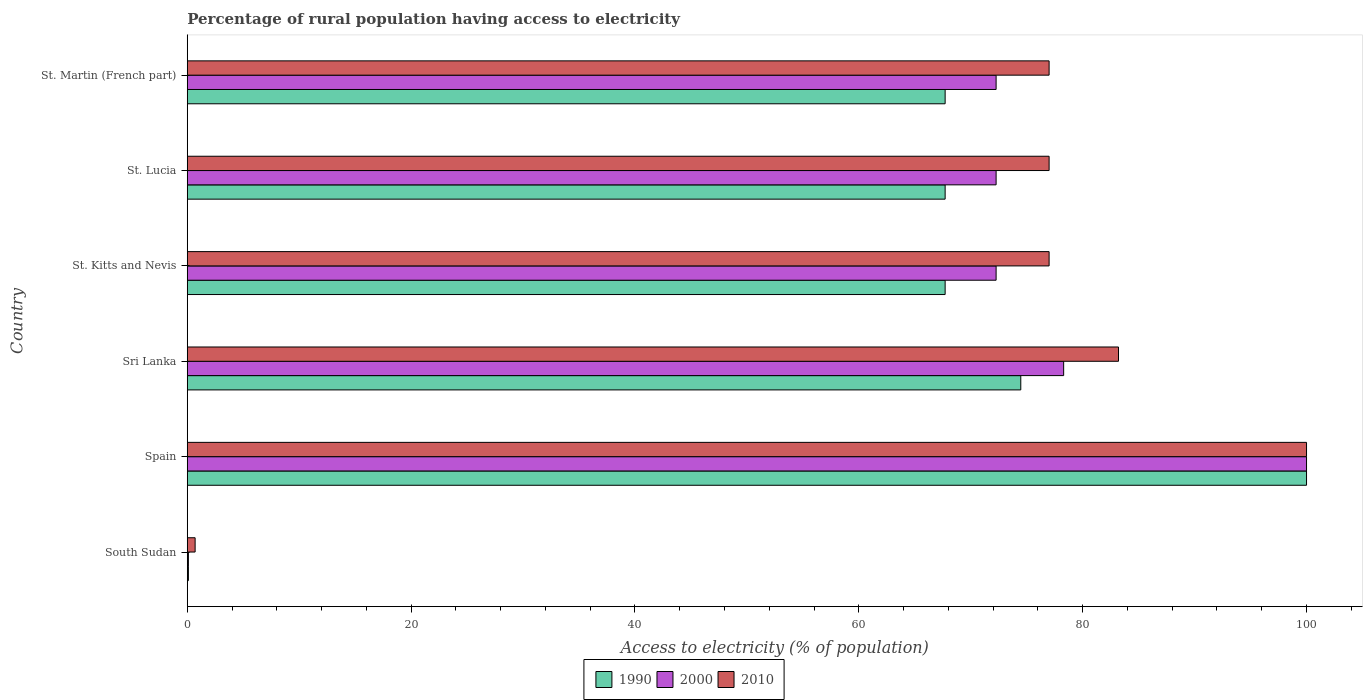How many groups of bars are there?
Offer a terse response. 6. Are the number of bars per tick equal to the number of legend labels?
Provide a short and direct response. Yes. Are the number of bars on each tick of the Y-axis equal?
Ensure brevity in your answer.  Yes. How many bars are there on the 4th tick from the bottom?
Provide a short and direct response. 3. What is the label of the 4th group of bars from the top?
Provide a succinct answer. Sri Lanka. What is the percentage of rural population having access to electricity in 2000 in South Sudan?
Offer a terse response. 0.1. In which country was the percentage of rural population having access to electricity in 2010 minimum?
Give a very brief answer. South Sudan. What is the total percentage of rural population having access to electricity in 1990 in the graph?
Provide a succinct answer. 377.7. What is the difference between the percentage of rural population having access to electricity in 2010 in Sri Lanka and that in St. Lucia?
Provide a succinct answer. 6.2. What is the difference between the percentage of rural population having access to electricity in 1990 in Sri Lanka and the percentage of rural population having access to electricity in 2000 in Spain?
Give a very brief answer. -25.53. What is the average percentage of rural population having access to electricity in 2000 per country?
Ensure brevity in your answer.  65.87. What is the difference between the percentage of rural population having access to electricity in 2010 and percentage of rural population having access to electricity in 2000 in St. Lucia?
Offer a terse response. 4.73. In how many countries, is the percentage of rural population having access to electricity in 1990 greater than 48 %?
Give a very brief answer. 5. What is the ratio of the percentage of rural population having access to electricity in 2000 in South Sudan to that in Spain?
Give a very brief answer. 0. Is the percentage of rural population having access to electricity in 2010 in Spain less than that in Sri Lanka?
Offer a terse response. No. Is the difference between the percentage of rural population having access to electricity in 2010 in St. Lucia and St. Martin (French part) greater than the difference between the percentage of rural population having access to electricity in 2000 in St. Lucia and St. Martin (French part)?
Offer a terse response. No. What is the difference between the highest and the second highest percentage of rural population having access to electricity in 2000?
Provide a succinct answer. 21.7. What is the difference between the highest and the lowest percentage of rural population having access to electricity in 2000?
Your answer should be compact. 99.9. What does the 2nd bar from the top in St. Martin (French part) represents?
Provide a succinct answer. 2000. Is it the case that in every country, the sum of the percentage of rural population having access to electricity in 1990 and percentage of rural population having access to electricity in 2010 is greater than the percentage of rural population having access to electricity in 2000?
Offer a very short reply. Yes. How many bars are there?
Your response must be concise. 18. How many countries are there in the graph?
Your answer should be very brief. 6. What is the difference between two consecutive major ticks on the X-axis?
Offer a terse response. 20. Are the values on the major ticks of X-axis written in scientific E-notation?
Offer a very short reply. No. Where does the legend appear in the graph?
Your answer should be compact. Bottom center. How many legend labels are there?
Ensure brevity in your answer.  3. What is the title of the graph?
Keep it short and to the point. Percentage of rural population having access to electricity. Does "1976" appear as one of the legend labels in the graph?
Offer a very short reply. No. What is the label or title of the X-axis?
Offer a terse response. Access to electricity (% of population). What is the Access to electricity (% of population) in 1990 in South Sudan?
Ensure brevity in your answer.  0.1. What is the Access to electricity (% of population) of 1990 in Spain?
Offer a very short reply. 100. What is the Access to electricity (% of population) in 1990 in Sri Lanka?
Provide a succinct answer. 74.47. What is the Access to electricity (% of population) of 2000 in Sri Lanka?
Your response must be concise. 78.3. What is the Access to electricity (% of population) of 2010 in Sri Lanka?
Keep it short and to the point. 83.2. What is the Access to electricity (% of population) of 1990 in St. Kitts and Nevis?
Provide a short and direct response. 67.71. What is the Access to electricity (% of population) of 2000 in St. Kitts and Nevis?
Keep it short and to the point. 72.27. What is the Access to electricity (% of population) of 2010 in St. Kitts and Nevis?
Your answer should be very brief. 77. What is the Access to electricity (% of population) of 1990 in St. Lucia?
Offer a very short reply. 67.71. What is the Access to electricity (% of population) in 2000 in St. Lucia?
Offer a terse response. 72.27. What is the Access to electricity (% of population) in 2010 in St. Lucia?
Your answer should be very brief. 77. What is the Access to electricity (% of population) of 1990 in St. Martin (French part)?
Provide a succinct answer. 67.71. What is the Access to electricity (% of population) in 2000 in St. Martin (French part)?
Provide a short and direct response. 72.27. What is the Access to electricity (% of population) of 2010 in St. Martin (French part)?
Give a very brief answer. 77. Across all countries, what is the maximum Access to electricity (% of population) in 1990?
Offer a terse response. 100. Across all countries, what is the maximum Access to electricity (% of population) of 2000?
Provide a short and direct response. 100. Across all countries, what is the minimum Access to electricity (% of population) in 1990?
Offer a very short reply. 0.1. Across all countries, what is the minimum Access to electricity (% of population) in 2000?
Your response must be concise. 0.1. Across all countries, what is the minimum Access to electricity (% of population) of 2010?
Your response must be concise. 0.7. What is the total Access to electricity (% of population) in 1990 in the graph?
Give a very brief answer. 377.7. What is the total Access to electricity (% of population) in 2000 in the graph?
Give a very brief answer. 395.2. What is the total Access to electricity (% of population) in 2010 in the graph?
Keep it short and to the point. 414.9. What is the difference between the Access to electricity (% of population) of 1990 in South Sudan and that in Spain?
Give a very brief answer. -99.9. What is the difference between the Access to electricity (% of population) in 2000 in South Sudan and that in Spain?
Ensure brevity in your answer.  -99.9. What is the difference between the Access to electricity (% of population) of 2010 in South Sudan and that in Spain?
Provide a short and direct response. -99.3. What is the difference between the Access to electricity (% of population) of 1990 in South Sudan and that in Sri Lanka?
Provide a short and direct response. -74.37. What is the difference between the Access to electricity (% of population) in 2000 in South Sudan and that in Sri Lanka?
Your response must be concise. -78.2. What is the difference between the Access to electricity (% of population) in 2010 in South Sudan and that in Sri Lanka?
Your response must be concise. -82.5. What is the difference between the Access to electricity (% of population) of 1990 in South Sudan and that in St. Kitts and Nevis?
Offer a terse response. -67.61. What is the difference between the Access to electricity (% of population) in 2000 in South Sudan and that in St. Kitts and Nevis?
Offer a very short reply. -72.17. What is the difference between the Access to electricity (% of population) of 2010 in South Sudan and that in St. Kitts and Nevis?
Offer a terse response. -76.3. What is the difference between the Access to electricity (% of population) in 1990 in South Sudan and that in St. Lucia?
Provide a succinct answer. -67.61. What is the difference between the Access to electricity (% of population) in 2000 in South Sudan and that in St. Lucia?
Your answer should be compact. -72.17. What is the difference between the Access to electricity (% of population) of 2010 in South Sudan and that in St. Lucia?
Offer a very short reply. -76.3. What is the difference between the Access to electricity (% of population) in 1990 in South Sudan and that in St. Martin (French part)?
Keep it short and to the point. -67.61. What is the difference between the Access to electricity (% of population) of 2000 in South Sudan and that in St. Martin (French part)?
Your answer should be very brief. -72.17. What is the difference between the Access to electricity (% of population) in 2010 in South Sudan and that in St. Martin (French part)?
Make the answer very short. -76.3. What is the difference between the Access to electricity (% of population) of 1990 in Spain and that in Sri Lanka?
Your response must be concise. 25.53. What is the difference between the Access to electricity (% of population) in 2000 in Spain and that in Sri Lanka?
Give a very brief answer. 21.7. What is the difference between the Access to electricity (% of population) in 2010 in Spain and that in Sri Lanka?
Your answer should be compact. 16.8. What is the difference between the Access to electricity (% of population) of 1990 in Spain and that in St. Kitts and Nevis?
Offer a very short reply. 32.29. What is the difference between the Access to electricity (% of population) of 2000 in Spain and that in St. Kitts and Nevis?
Provide a short and direct response. 27.73. What is the difference between the Access to electricity (% of population) of 2010 in Spain and that in St. Kitts and Nevis?
Make the answer very short. 23. What is the difference between the Access to electricity (% of population) in 1990 in Spain and that in St. Lucia?
Provide a succinct answer. 32.29. What is the difference between the Access to electricity (% of population) of 2000 in Spain and that in St. Lucia?
Offer a terse response. 27.73. What is the difference between the Access to electricity (% of population) of 2010 in Spain and that in St. Lucia?
Offer a very short reply. 23. What is the difference between the Access to electricity (% of population) of 1990 in Spain and that in St. Martin (French part)?
Your response must be concise. 32.29. What is the difference between the Access to electricity (% of population) in 2000 in Spain and that in St. Martin (French part)?
Offer a terse response. 27.73. What is the difference between the Access to electricity (% of population) of 2010 in Spain and that in St. Martin (French part)?
Make the answer very short. 23. What is the difference between the Access to electricity (% of population) in 1990 in Sri Lanka and that in St. Kitts and Nevis?
Ensure brevity in your answer.  6.76. What is the difference between the Access to electricity (% of population) of 2000 in Sri Lanka and that in St. Kitts and Nevis?
Keep it short and to the point. 6.04. What is the difference between the Access to electricity (% of population) in 1990 in Sri Lanka and that in St. Lucia?
Your response must be concise. 6.76. What is the difference between the Access to electricity (% of population) in 2000 in Sri Lanka and that in St. Lucia?
Offer a very short reply. 6.04. What is the difference between the Access to electricity (% of population) of 2010 in Sri Lanka and that in St. Lucia?
Offer a very short reply. 6.2. What is the difference between the Access to electricity (% of population) of 1990 in Sri Lanka and that in St. Martin (French part)?
Offer a very short reply. 6.76. What is the difference between the Access to electricity (% of population) in 2000 in Sri Lanka and that in St. Martin (French part)?
Ensure brevity in your answer.  6.04. What is the difference between the Access to electricity (% of population) in 2010 in Sri Lanka and that in St. Martin (French part)?
Provide a succinct answer. 6.2. What is the difference between the Access to electricity (% of population) of 2010 in St. Kitts and Nevis and that in St. Lucia?
Your response must be concise. 0. What is the difference between the Access to electricity (% of population) of 1990 in St. Kitts and Nevis and that in St. Martin (French part)?
Offer a very short reply. 0. What is the difference between the Access to electricity (% of population) in 2000 in St. Kitts and Nevis and that in St. Martin (French part)?
Your answer should be very brief. 0. What is the difference between the Access to electricity (% of population) of 1990 in St. Lucia and that in St. Martin (French part)?
Provide a succinct answer. 0. What is the difference between the Access to electricity (% of population) of 2000 in St. Lucia and that in St. Martin (French part)?
Your answer should be very brief. 0. What is the difference between the Access to electricity (% of population) of 1990 in South Sudan and the Access to electricity (% of population) of 2000 in Spain?
Your answer should be compact. -99.9. What is the difference between the Access to electricity (% of population) of 1990 in South Sudan and the Access to electricity (% of population) of 2010 in Spain?
Keep it short and to the point. -99.9. What is the difference between the Access to electricity (% of population) of 2000 in South Sudan and the Access to electricity (% of population) of 2010 in Spain?
Make the answer very short. -99.9. What is the difference between the Access to electricity (% of population) in 1990 in South Sudan and the Access to electricity (% of population) in 2000 in Sri Lanka?
Your answer should be very brief. -78.2. What is the difference between the Access to electricity (% of population) of 1990 in South Sudan and the Access to electricity (% of population) of 2010 in Sri Lanka?
Your answer should be very brief. -83.1. What is the difference between the Access to electricity (% of population) in 2000 in South Sudan and the Access to electricity (% of population) in 2010 in Sri Lanka?
Your answer should be compact. -83.1. What is the difference between the Access to electricity (% of population) of 1990 in South Sudan and the Access to electricity (% of population) of 2000 in St. Kitts and Nevis?
Ensure brevity in your answer.  -72.17. What is the difference between the Access to electricity (% of population) of 1990 in South Sudan and the Access to electricity (% of population) of 2010 in St. Kitts and Nevis?
Give a very brief answer. -76.9. What is the difference between the Access to electricity (% of population) in 2000 in South Sudan and the Access to electricity (% of population) in 2010 in St. Kitts and Nevis?
Your response must be concise. -76.9. What is the difference between the Access to electricity (% of population) of 1990 in South Sudan and the Access to electricity (% of population) of 2000 in St. Lucia?
Ensure brevity in your answer.  -72.17. What is the difference between the Access to electricity (% of population) in 1990 in South Sudan and the Access to electricity (% of population) in 2010 in St. Lucia?
Provide a succinct answer. -76.9. What is the difference between the Access to electricity (% of population) in 2000 in South Sudan and the Access to electricity (% of population) in 2010 in St. Lucia?
Provide a succinct answer. -76.9. What is the difference between the Access to electricity (% of population) in 1990 in South Sudan and the Access to electricity (% of population) in 2000 in St. Martin (French part)?
Ensure brevity in your answer.  -72.17. What is the difference between the Access to electricity (% of population) in 1990 in South Sudan and the Access to electricity (% of population) in 2010 in St. Martin (French part)?
Give a very brief answer. -76.9. What is the difference between the Access to electricity (% of population) in 2000 in South Sudan and the Access to electricity (% of population) in 2010 in St. Martin (French part)?
Provide a succinct answer. -76.9. What is the difference between the Access to electricity (% of population) in 1990 in Spain and the Access to electricity (% of population) in 2000 in Sri Lanka?
Your answer should be very brief. 21.7. What is the difference between the Access to electricity (% of population) in 1990 in Spain and the Access to electricity (% of population) in 2000 in St. Kitts and Nevis?
Your answer should be compact. 27.73. What is the difference between the Access to electricity (% of population) in 1990 in Spain and the Access to electricity (% of population) in 2000 in St. Lucia?
Your answer should be compact. 27.73. What is the difference between the Access to electricity (% of population) in 2000 in Spain and the Access to electricity (% of population) in 2010 in St. Lucia?
Keep it short and to the point. 23. What is the difference between the Access to electricity (% of population) of 1990 in Spain and the Access to electricity (% of population) of 2000 in St. Martin (French part)?
Make the answer very short. 27.73. What is the difference between the Access to electricity (% of population) in 1990 in Spain and the Access to electricity (% of population) in 2010 in St. Martin (French part)?
Ensure brevity in your answer.  23. What is the difference between the Access to electricity (% of population) in 2000 in Spain and the Access to electricity (% of population) in 2010 in St. Martin (French part)?
Offer a very short reply. 23. What is the difference between the Access to electricity (% of population) in 1990 in Sri Lanka and the Access to electricity (% of population) in 2000 in St. Kitts and Nevis?
Make the answer very short. 2.2. What is the difference between the Access to electricity (% of population) of 1990 in Sri Lanka and the Access to electricity (% of population) of 2010 in St. Kitts and Nevis?
Keep it short and to the point. -2.53. What is the difference between the Access to electricity (% of population) of 2000 in Sri Lanka and the Access to electricity (% of population) of 2010 in St. Kitts and Nevis?
Your response must be concise. 1.3. What is the difference between the Access to electricity (% of population) in 1990 in Sri Lanka and the Access to electricity (% of population) in 2000 in St. Lucia?
Offer a terse response. 2.2. What is the difference between the Access to electricity (% of population) in 1990 in Sri Lanka and the Access to electricity (% of population) in 2010 in St. Lucia?
Give a very brief answer. -2.53. What is the difference between the Access to electricity (% of population) in 1990 in Sri Lanka and the Access to electricity (% of population) in 2000 in St. Martin (French part)?
Your answer should be very brief. 2.2. What is the difference between the Access to electricity (% of population) of 1990 in Sri Lanka and the Access to electricity (% of population) of 2010 in St. Martin (French part)?
Offer a very short reply. -2.53. What is the difference between the Access to electricity (% of population) in 1990 in St. Kitts and Nevis and the Access to electricity (% of population) in 2000 in St. Lucia?
Provide a succinct answer. -4.55. What is the difference between the Access to electricity (% of population) in 1990 in St. Kitts and Nevis and the Access to electricity (% of population) in 2010 in St. Lucia?
Offer a terse response. -9.29. What is the difference between the Access to electricity (% of population) in 2000 in St. Kitts and Nevis and the Access to electricity (% of population) in 2010 in St. Lucia?
Provide a short and direct response. -4.74. What is the difference between the Access to electricity (% of population) of 1990 in St. Kitts and Nevis and the Access to electricity (% of population) of 2000 in St. Martin (French part)?
Ensure brevity in your answer.  -4.55. What is the difference between the Access to electricity (% of population) of 1990 in St. Kitts and Nevis and the Access to electricity (% of population) of 2010 in St. Martin (French part)?
Offer a terse response. -9.29. What is the difference between the Access to electricity (% of population) in 2000 in St. Kitts and Nevis and the Access to electricity (% of population) in 2010 in St. Martin (French part)?
Your answer should be compact. -4.74. What is the difference between the Access to electricity (% of population) of 1990 in St. Lucia and the Access to electricity (% of population) of 2000 in St. Martin (French part)?
Your answer should be very brief. -4.55. What is the difference between the Access to electricity (% of population) in 1990 in St. Lucia and the Access to electricity (% of population) in 2010 in St. Martin (French part)?
Keep it short and to the point. -9.29. What is the difference between the Access to electricity (% of population) in 2000 in St. Lucia and the Access to electricity (% of population) in 2010 in St. Martin (French part)?
Give a very brief answer. -4.74. What is the average Access to electricity (% of population) in 1990 per country?
Keep it short and to the point. 62.95. What is the average Access to electricity (% of population) in 2000 per country?
Make the answer very short. 65.87. What is the average Access to electricity (% of population) in 2010 per country?
Offer a terse response. 69.15. What is the difference between the Access to electricity (% of population) of 1990 and Access to electricity (% of population) of 2010 in South Sudan?
Provide a short and direct response. -0.6. What is the difference between the Access to electricity (% of population) in 2000 and Access to electricity (% of population) in 2010 in South Sudan?
Your response must be concise. -0.6. What is the difference between the Access to electricity (% of population) of 1990 and Access to electricity (% of population) of 2000 in Spain?
Provide a short and direct response. 0. What is the difference between the Access to electricity (% of population) in 1990 and Access to electricity (% of population) in 2010 in Spain?
Provide a succinct answer. 0. What is the difference between the Access to electricity (% of population) in 1990 and Access to electricity (% of population) in 2000 in Sri Lanka?
Offer a terse response. -3.83. What is the difference between the Access to electricity (% of population) in 1990 and Access to electricity (% of population) in 2010 in Sri Lanka?
Keep it short and to the point. -8.73. What is the difference between the Access to electricity (% of population) of 1990 and Access to electricity (% of population) of 2000 in St. Kitts and Nevis?
Offer a very short reply. -4.55. What is the difference between the Access to electricity (% of population) of 1990 and Access to electricity (% of population) of 2010 in St. Kitts and Nevis?
Offer a very short reply. -9.29. What is the difference between the Access to electricity (% of population) in 2000 and Access to electricity (% of population) in 2010 in St. Kitts and Nevis?
Provide a short and direct response. -4.74. What is the difference between the Access to electricity (% of population) in 1990 and Access to electricity (% of population) in 2000 in St. Lucia?
Give a very brief answer. -4.55. What is the difference between the Access to electricity (% of population) in 1990 and Access to electricity (% of population) in 2010 in St. Lucia?
Ensure brevity in your answer.  -9.29. What is the difference between the Access to electricity (% of population) in 2000 and Access to electricity (% of population) in 2010 in St. Lucia?
Ensure brevity in your answer.  -4.74. What is the difference between the Access to electricity (% of population) in 1990 and Access to electricity (% of population) in 2000 in St. Martin (French part)?
Offer a very short reply. -4.55. What is the difference between the Access to electricity (% of population) in 1990 and Access to electricity (% of population) in 2010 in St. Martin (French part)?
Give a very brief answer. -9.29. What is the difference between the Access to electricity (% of population) in 2000 and Access to electricity (% of population) in 2010 in St. Martin (French part)?
Provide a short and direct response. -4.74. What is the ratio of the Access to electricity (% of population) in 1990 in South Sudan to that in Spain?
Your answer should be very brief. 0. What is the ratio of the Access to electricity (% of population) in 2000 in South Sudan to that in Spain?
Provide a short and direct response. 0. What is the ratio of the Access to electricity (% of population) of 2010 in South Sudan to that in Spain?
Give a very brief answer. 0.01. What is the ratio of the Access to electricity (% of population) in 1990 in South Sudan to that in Sri Lanka?
Offer a very short reply. 0. What is the ratio of the Access to electricity (% of population) in 2000 in South Sudan to that in Sri Lanka?
Make the answer very short. 0. What is the ratio of the Access to electricity (% of population) in 2010 in South Sudan to that in Sri Lanka?
Make the answer very short. 0.01. What is the ratio of the Access to electricity (% of population) of 1990 in South Sudan to that in St. Kitts and Nevis?
Make the answer very short. 0. What is the ratio of the Access to electricity (% of population) of 2000 in South Sudan to that in St. Kitts and Nevis?
Provide a short and direct response. 0. What is the ratio of the Access to electricity (% of population) in 2010 in South Sudan to that in St. Kitts and Nevis?
Offer a very short reply. 0.01. What is the ratio of the Access to electricity (% of population) in 1990 in South Sudan to that in St. Lucia?
Give a very brief answer. 0. What is the ratio of the Access to electricity (% of population) in 2000 in South Sudan to that in St. Lucia?
Offer a terse response. 0. What is the ratio of the Access to electricity (% of population) in 2010 in South Sudan to that in St. Lucia?
Make the answer very short. 0.01. What is the ratio of the Access to electricity (% of population) of 1990 in South Sudan to that in St. Martin (French part)?
Your response must be concise. 0. What is the ratio of the Access to electricity (% of population) in 2000 in South Sudan to that in St. Martin (French part)?
Ensure brevity in your answer.  0. What is the ratio of the Access to electricity (% of population) in 2010 in South Sudan to that in St. Martin (French part)?
Your answer should be compact. 0.01. What is the ratio of the Access to electricity (% of population) in 1990 in Spain to that in Sri Lanka?
Provide a short and direct response. 1.34. What is the ratio of the Access to electricity (% of population) in 2000 in Spain to that in Sri Lanka?
Keep it short and to the point. 1.28. What is the ratio of the Access to electricity (% of population) of 2010 in Spain to that in Sri Lanka?
Make the answer very short. 1.2. What is the ratio of the Access to electricity (% of population) in 1990 in Spain to that in St. Kitts and Nevis?
Offer a terse response. 1.48. What is the ratio of the Access to electricity (% of population) in 2000 in Spain to that in St. Kitts and Nevis?
Provide a succinct answer. 1.38. What is the ratio of the Access to electricity (% of population) of 2010 in Spain to that in St. Kitts and Nevis?
Ensure brevity in your answer.  1.3. What is the ratio of the Access to electricity (% of population) in 1990 in Spain to that in St. Lucia?
Your answer should be very brief. 1.48. What is the ratio of the Access to electricity (% of population) in 2000 in Spain to that in St. Lucia?
Give a very brief answer. 1.38. What is the ratio of the Access to electricity (% of population) in 2010 in Spain to that in St. Lucia?
Offer a terse response. 1.3. What is the ratio of the Access to electricity (% of population) in 1990 in Spain to that in St. Martin (French part)?
Ensure brevity in your answer.  1.48. What is the ratio of the Access to electricity (% of population) in 2000 in Spain to that in St. Martin (French part)?
Your answer should be very brief. 1.38. What is the ratio of the Access to electricity (% of population) of 2010 in Spain to that in St. Martin (French part)?
Give a very brief answer. 1.3. What is the ratio of the Access to electricity (% of population) of 1990 in Sri Lanka to that in St. Kitts and Nevis?
Give a very brief answer. 1.1. What is the ratio of the Access to electricity (% of population) of 2000 in Sri Lanka to that in St. Kitts and Nevis?
Provide a short and direct response. 1.08. What is the ratio of the Access to electricity (% of population) in 2010 in Sri Lanka to that in St. Kitts and Nevis?
Keep it short and to the point. 1.08. What is the ratio of the Access to electricity (% of population) of 1990 in Sri Lanka to that in St. Lucia?
Offer a terse response. 1.1. What is the ratio of the Access to electricity (% of population) of 2000 in Sri Lanka to that in St. Lucia?
Provide a succinct answer. 1.08. What is the ratio of the Access to electricity (% of population) in 2010 in Sri Lanka to that in St. Lucia?
Your answer should be compact. 1.08. What is the ratio of the Access to electricity (% of population) of 1990 in Sri Lanka to that in St. Martin (French part)?
Offer a very short reply. 1.1. What is the ratio of the Access to electricity (% of population) in 2000 in Sri Lanka to that in St. Martin (French part)?
Your answer should be compact. 1.08. What is the ratio of the Access to electricity (% of population) of 2010 in Sri Lanka to that in St. Martin (French part)?
Keep it short and to the point. 1.08. What is the ratio of the Access to electricity (% of population) of 2000 in St. Kitts and Nevis to that in St. Lucia?
Provide a succinct answer. 1. What is the ratio of the Access to electricity (% of population) in 2010 in St. Kitts and Nevis to that in St. Martin (French part)?
Offer a very short reply. 1. What is the ratio of the Access to electricity (% of population) of 1990 in St. Lucia to that in St. Martin (French part)?
Ensure brevity in your answer.  1. What is the ratio of the Access to electricity (% of population) in 2000 in St. Lucia to that in St. Martin (French part)?
Give a very brief answer. 1. What is the difference between the highest and the second highest Access to electricity (% of population) of 1990?
Offer a terse response. 25.53. What is the difference between the highest and the second highest Access to electricity (% of population) of 2000?
Give a very brief answer. 21.7. What is the difference between the highest and the second highest Access to electricity (% of population) in 2010?
Your answer should be compact. 16.8. What is the difference between the highest and the lowest Access to electricity (% of population) in 1990?
Ensure brevity in your answer.  99.9. What is the difference between the highest and the lowest Access to electricity (% of population) in 2000?
Your answer should be very brief. 99.9. What is the difference between the highest and the lowest Access to electricity (% of population) of 2010?
Ensure brevity in your answer.  99.3. 